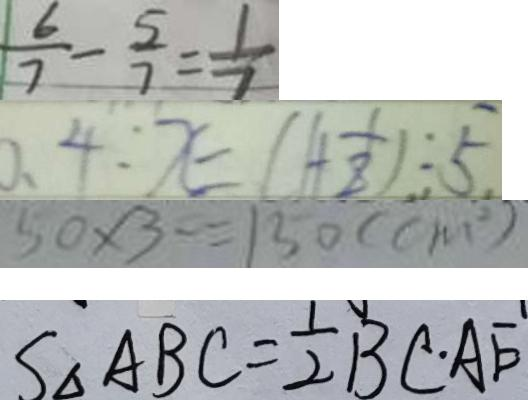<formula> <loc_0><loc_0><loc_500><loc_500>\frac { 6 } { 7 } - \frac { 5 } { 7 } = \frac { 1 } { 7 } 
 0 . 4 : x = ( 1 + \frac { 1 } { 8 } ) : 5 
 5 0 \times 3 = 1 3 0 ( c m ^ { 2 } ) 
 S _ { \Delta A B C } = \frac { 1 } { 2 } B C \cdot A E</formula> 